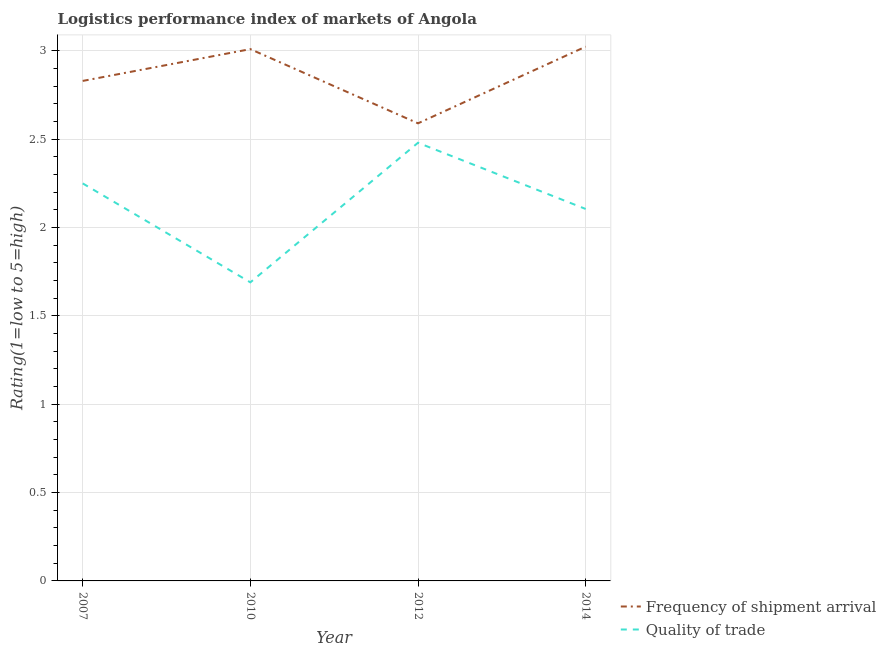How many different coloured lines are there?
Make the answer very short. 2. What is the lpi of frequency of shipment arrival in 2010?
Your answer should be very brief. 3.01. Across all years, what is the maximum lpi of frequency of shipment arrival?
Your answer should be very brief. 3.02. Across all years, what is the minimum lpi of frequency of shipment arrival?
Keep it short and to the point. 2.59. In which year was the lpi quality of trade maximum?
Provide a short and direct response. 2012. In which year was the lpi of frequency of shipment arrival minimum?
Provide a short and direct response. 2012. What is the total lpi of frequency of shipment arrival in the graph?
Provide a short and direct response. 11.45. What is the difference between the lpi of frequency of shipment arrival in 2007 and that in 2010?
Your response must be concise. -0.18. What is the difference between the lpi quality of trade in 2010 and the lpi of frequency of shipment arrival in 2014?
Ensure brevity in your answer.  -1.33. What is the average lpi quality of trade per year?
Provide a succinct answer. 2.13. In the year 2010, what is the difference between the lpi of frequency of shipment arrival and lpi quality of trade?
Provide a succinct answer. 1.32. What is the ratio of the lpi quality of trade in 2007 to that in 2014?
Your answer should be very brief. 1.07. Is the lpi quality of trade in 2007 less than that in 2014?
Give a very brief answer. No. Is the difference between the lpi of frequency of shipment arrival in 2010 and 2012 greater than the difference between the lpi quality of trade in 2010 and 2012?
Ensure brevity in your answer.  Yes. What is the difference between the highest and the second highest lpi of frequency of shipment arrival?
Your response must be concise. 0.01. What is the difference between the highest and the lowest lpi quality of trade?
Keep it short and to the point. 0.79. Is the sum of the lpi quality of trade in 2010 and 2014 greater than the maximum lpi of frequency of shipment arrival across all years?
Your answer should be compact. Yes. How many lines are there?
Ensure brevity in your answer.  2. How many years are there in the graph?
Ensure brevity in your answer.  4. Are the values on the major ticks of Y-axis written in scientific E-notation?
Make the answer very short. No. How many legend labels are there?
Offer a very short reply. 2. How are the legend labels stacked?
Offer a terse response. Vertical. What is the title of the graph?
Your answer should be compact. Logistics performance index of markets of Angola. What is the label or title of the Y-axis?
Your answer should be very brief. Rating(1=low to 5=high). What is the Rating(1=low to 5=high) in Frequency of shipment arrival in 2007?
Ensure brevity in your answer.  2.83. What is the Rating(1=low to 5=high) in Quality of trade in 2007?
Make the answer very short. 2.25. What is the Rating(1=low to 5=high) of Frequency of shipment arrival in 2010?
Keep it short and to the point. 3.01. What is the Rating(1=low to 5=high) of Quality of trade in 2010?
Give a very brief answer. 1.69. What is the Rating(1=low to 5=high) in Frequency of shipment arrival in 2012?
Keep it short and to the point. 2.59. What is the Rating(1=low to 5=high) of Quality of trade in 2012?
Offer a terse response. 2.48. What is the Rating(1=low to 5=high) in Frequency of shipment arrival in 2014?
Keep it short and to the point. 3.02. What is the Rating(1=low to 5=high) in Quality of trade in 2014?
Give a very brief answer. 2.11. Across all years, what is the maximum Rating(1=low to 5=high) in Frequency of shipment arrival?
Ensure brevity in your answer.  3.02. Across all years, what is the maximum Rating(1=low to 5=high) of Quality of trade?
Your answer should be very brief. 2.48. Across all years, what is the minimum Rating(1=low to 5=high) in Frequency of shipment arrival?
Your answer should be very brief. 2.59. Across all years, what is the minimum Rating(1=low to 5=high) in Quality of trade?
Give a very brief answer. 1.69. What is the total Rating(1=low to 5=high) of Frequency of shipment arrival in the graph?
Make the answer very short. 11.45. What is the total Rating(1=low to 5=high) in Quality of trade in the graph?
Your answer should be compact. 8.53. What is the difference between the Rating(1=low to 5=high) in Frequency of shipment arrival in 2007 and that in 2010?
Offer a terse response. -0.18. What is the difference between the Rating(1=low to 5=high) of Quality of trade in 2007 and that in 2010?
Provide a succinct answer. 0.56. What is the difference between the Rating(1=low to 5=high) of Frequency of shipment arrival in 2007 and that in 2012?
Offer a terse response. 0.24. What is the difference between the Rating(1=low to 5=high) in Quality of trade in 2007 and that in 2012?
Make the answer very short. -0.23. What is the difference between the Rating(1=low to 5=high) in Frequency of shipment arrival in 2007 and that in 2014?
Provide a succinct answer. -0.19. What is the difference between the Rating(1=low to 5=high) in Quality of trade in 2007 and that in 2014?
Ensure brevity in your answer.  0.14. What is the difference between the Rating(1=low to 5=high) of Frequency of shipment arrival in 2010 and that in 2012?
Offer a very short reply. 0.42. What is the difference between the Rating(1=low to 5=high) in Quality of trade in 2010 and that in 2012?
Keep it short and to the point. -0.79. What is the difference between the Rating(1=low to 5=high) in Frequency of shipment arrival in 2010 and that in 2014?
Make the answer very short. -0.01. What is the difference between the Rating(1=low to 5=high) of Quality of trade in 2010 and that in 2014?
Make the answer very short. -0.42. What is the difference between the Rating(1=low to 5=high) of Frequency of shipment arrival in 2012 and that in 2014?
Ensure brevity in your answer.  -0.43. What is the difference between the Rating(1=low to 5=high) of Quality of trade in 2012 and that in 2014?
Make the answer very short. 0.37. What is the difference between the Rating(1=low to 5=high) in Frequency of shipment arrival in 2007 and the Rating(1=low to 5=high) in Quality of trade in 2010?
Your answer should be very brief. 1.14. What is the difference between the Rating(1=low to 5=high) in Frequency of shipment arrival in 2007 and the Rating(1=low to 5=high) in Quality of trade in 2014?
Give a very brief answer. 0.72. What is the difference between the Rating(1=low to 5=high) of Frequency of shipment arrival in 2010 and the Rating(1=low to 5=high) of Quality of trade in 2012?
Offer a very short reply. 0.53. What is the difference between the Rating(1=low to 5=high) in Frequency of shipment arrival in 2010 and the Rating(1=low to 5=high) in Quality of trade in 2014?
Your response must be concise. 0.9. What is the difference between the Rating(1=low to 5=high) of Frequency of shipment arrival in 2012 and the Rating(1=low to 5=high) of Quality of trade in 2014?
Your answer should be compact. 0.48. What is the average Rating(1=low to 5=high) of Frequency of shipment arrival per year?
Your answer should be compact. 2.86. What is the average Rating(1=low to 5=high) of Quality of trade per year?
Make the answer very short. 2.13. In the year 2007, what is the difference between the Rating(1=low to 5=high) of Frequency of shipment arrival and Rating(1=low to 5=high) of Quality of trade?
Offer a very short reply. 0.58. In the year 2010, what is the difference between the Rating(1=low to 5=high) in Frequency of shipment arrival and Rating(1=low to 5=high) in Quality of trade?
Your response must be concise. 1.32. In the year 2012, what is the difference between the Rating(1=low to 5=high) of Frequency of shipment arrival and Rating(1=low to 5=high) of Quality of trade?
Your answer should be very brief. 0.11. In the year 2014, what is the difference between the Rating(1=low to 5=high) in Frequency of shipment arrival and Rating(1=low to 5=high) in Quality of trade?
Offer a very short reply. 0.92. What is the ratio of the Rating(1=low to 5=high) of Frequency of shipment arrival in 2007 to that in 2010?
Ensure brevity in your answer.  0.94. What is the ratio of the Rating(1=low to 5=high) in Quality of trade in 2007 to that in 2010?
Offer a terse response. 1.33. What is the ratio of the Rating(1=low to 5=high) in Frequency of shipment arrival in 2007 to that in 2012?
Give a very brief answer. 1.09. What is the ratio of the Rating(1=low to 5=high) of Quality of trade in 2007 to that in 2012?
Your answer should be compact. 0.91. What is the ratio of the Rating(1=low to 5=high) of Frequency of shipment arrival in 2007 to that in 2014?
Your answer should be very brief. 0.94. What is the ratio of the Rating(1=low to 5=high) in Quality of trade in 2007 to that in 2014?
Your answer should be very brief. 1.07. What is the ratio of the Rating(1=low to 5=high) of Frequency of shipment arrival in 2010 to that in 2012?
Keep it short and to the point. 1.16. What is the ratio of the Rating(1=low to 5=high) of Quality of trade in 2010 to that in 2012?
Provide a short and direct response. 0.68. What is the ratio of the Rating(1=low to 5=high) in Frequency of shipment arrival in 2010 to that in 2014?
Provide a short and direct response. 1. What is the ratio of the Rating(1=low to 5=high) of Quality of trade in 2010 to that in 2014?
Offer a very short reply. 0.8. What is the ratio of the Rating(1=low to 5=high) in Frequency of shipment arrival in 2012 to that in 2014?
Ensure brevity in your answer.  0.86. What is the ratio of the Rating(1=low to 5=high) in Quality of trade in 2012 to that in 2014?
Provide a short and direct response. 1.18. What is the difference between the highest and the second highest Rating(1=low to 5=high) in Frequency of shipment arrival?
Make the answer very short. 0.01. What is the difference between the highest and the second highest Rating(1=low to 5=high) of Quality of trade?
Offer a terse response. 0.23. What is the difference between the highest and the lowest Rating(1=low to 5=high) of Frequency of shipment arrival?
Your answer should be very brief. 0.43. What is the difference between the highest and the lowest Rating(1=low to 5=high) in Quality of trade?
Make the answer very short. 0.79. 